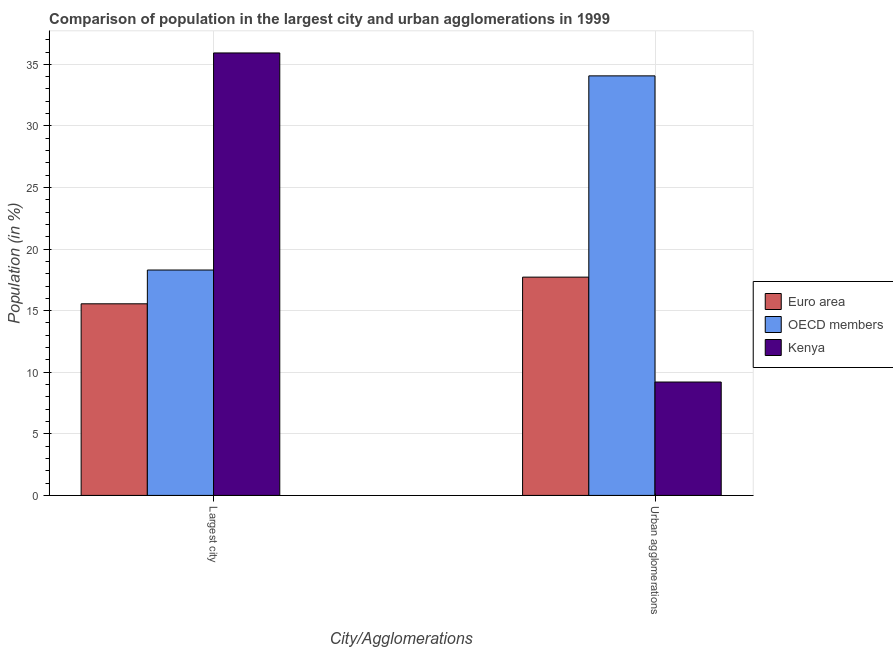Are the number of bars on each tick of the X-axis equal?
Keep it short and to the point. Yes. How many bars are there on the 2nd tick from the left?
Provide a short and direct response. 3. How many bars are there on the 2nd tick from the right?
Give a very brief answer. 3. What is the label of the 2nd group of bars from the left?
Ensure brevity in your answer.  Urban agglomerations. What is the population in the largest city in OECD members?
Make the answer very short. 18.3. Across all countries, what is the maximum population in urban agglomerations?
Keep it short and to the point. 34.06. Across all countries, what is the minimum population in the largest city?
Your answer should be very brief. 15.56. In which country was the population in the largest city maximum?
Offer a terse response. Kenya. In which country was the population in urban agglomerations minimum?
Provide a short and direct response. Kenya. What is the total population in the largest city in the graph?
Offer a very short reply. 69.78. What is the difference between the population in urban agglomerations in Kenya and that in Euro area?
Give a very brief answer. -8.52. What is the difference between the population in urban agglomerations in Kenya and the population in the largest city in OECD members?
Keep it short and to the point. -9.09. What is the average population in the largest city per country?
Your response must be concise. 23.26. What is the difference between the population in the largest city and population in urban agglomerations in Kenya?
Offer a terse response. 26.72. What is the ratio of the population in the largest city in Euro area to that in Kenya?
Ensure brevity in your answer.  0.43. How many bars are there?
Offer a terse response. 6. Are all the bars in the graph horizontal?
Ensure brevity in your answer.  No. How many countries are there in the graph?
Provide a succinct answer. 3. What is the difference between two consecutive major ticks on the Y-axis?
Make the answer very short. 5. Does the graph contain any zero values?
Give a very brief answer. No. How are the legend labels stacked?
Provide a succinct answer. Vertical. What is the title of the graph?
Offer a very short reply. Comparison of population in the largest city and urban agglomerations in 1999. Does "St. Vincent and the Grenadines" appear as one of the legend labels in the graph?
Your answer should be compact. No. What is the label or title of the X-axis?
Your answer should be very brief. City/Agglomerations. What is the label or title of the Y-axis?
Keep it short and to the point. Population (in %). What is the Population (in %) in Euro area in Largest city?
Your response must be concise. 15.56. What is the Population (in %) of OECD members in Largest city?
Provide a succinct answer. 18.3. What is the Population (in %) of Kenya in Largest city?
Provide a succinct answer. 35.92. What is the Population (in %) of Euro area in Urban agglomerations?
Provide a succinct answer. 17.72. What is the Population (in %) of OECD members in Urban agglomerations?
Offer a terse response. 34.06. What is the Population (in %) in Kenya in Urban agglomerations?
Offer a terse response. 9.21. Across all City/Agglomerations, what is the maximum Population (in %) of Euro area?
Give a very brief answer. 17.72. Across all City/Agglomerations, what is the maximum Population (in %) of OECD members?
Offer a terse response. 34.06. Across all City/Agglomerations, what is the maximum Population (in %) of Kenya?
Your answer should be compact. 35.92. Across all City/Agglomerations, what is the minimum Population (in %) in Euro area?
Make the answer very short. 15.56. Across all City/Agglomerations, what is the minimum Population (in %) in OECD members?
Offer a very short reply. 18.3. Across all City/Agglomerations, what is the minimum Population (in %) in Kenya?
Offer a very short reply. 9.21. What is the total Population (in %) of Euro area in the graph?
Give a very brief answer. 33.28. What is the total Population (in %) of OECD members in the graph?
Your response must be concise. 52.36. What is the total Population (in %) of Kenya in the graph?
Provide a short and direct response. 45.13. What is the difference between the Population (in %) of Euro area in Largest city and that in Urban agglomerations?
Offer a very short reply. -2.17. What is the difference between the Population (in %) of OECD members in Largest city and that in Urban agglomerations?
Give a very brief answer. -15.76. What is the difference between the Population (in %) in Kenya in Largest city and that in Urban agglomerations?
Make the answer very short. 26.72. What is the difference between the Population (in %) in Euro area in Largest city and the Population (in %) in OECD members in Urban agglomerations?
Keep it short and to the point. -18.51. What is the difference between the Population (in %) in Euro area in Largest city and the Population (in %) in Kenya in Urban agglomerations?
Keep it short and to the point. 6.35. What is the difference between the Population (in %) of OECD members in Largest city and the Population (in %) of Kenya in Urban agglomerations?
Your answer should be very brief. 9.09. What is the average Population (in %) in Euro area per City/Agglomerations?
Provide a short and direct response. 16.64. What is the average Population (in %) in OECD members per City/Agglomerations?
Your answer should be compact. 26.18. What is the average Population (in %) in Kenya per City/Agglomerations?
Your answer should be compact. 22.56. What is the difference between the Population (in %) in Euro area and Population (in %) in OECD members in Largest city?
Offer a terse response. -2.74. What is the difference between the Population (in %) of Euro area and Population (in %) of Kenya in Largest city?
Offer a very short reply. -20.37. What is the difference between the Population (in %) in OECD members and Population (in %) in Kenya in Largest city?
Your answer should be compact. -17.62. What is the difference between the Population (in %) of Euro area and Population (in %) of OECD members in Urban agglomerations?
Give a very brief answer. -16.34. What is the difference between the Population (in %) of Euro area and Population (in %) of Kenya in Urban agglomerations?
Provide a succinct answer. 8.52. What is the difference between the Population (in %) of OECD members and Population (in %) of Kenya in Urban agglomerations?
Give a very brief answer. 24.86. What is the ratio of the Population (in %) of Euro area in Largest city to that in Urban agglomerations?
Ensure brevity in your answer.  0.88. What is the ratio of the Population (in %) of OECD members in Largest city to that in Urban agglomerations?
Offer a terse response. 0.54. What is the ratio of the Population (in %) in Kenya in Largest city to that in Urban agglomerations?
Provide a succinct answer. 3.9. What is the difference between the highest and the second highest Population (in %) of Euro area?
Ensure brevity in your answer.  2.17. What is the difference between the highest and the second highest Population (in %) of OECD members?
Give a very brief answer. 15.76. What is the difference between the highest and the second highest Population (in %) in Kenya?
Give a very brief answer. 26.72. What is the difference between the highest and the lowest Population (in %) in Euro area?
Make the answer very short. 2.17. What is the difference between the highest and the lowest Population (in %) of OECD members?
Offer a very short reply. 15.76. What is the difference between the highest and the lowest Population (in %) of Kenya?
Your answer should be compact. 26.72. 